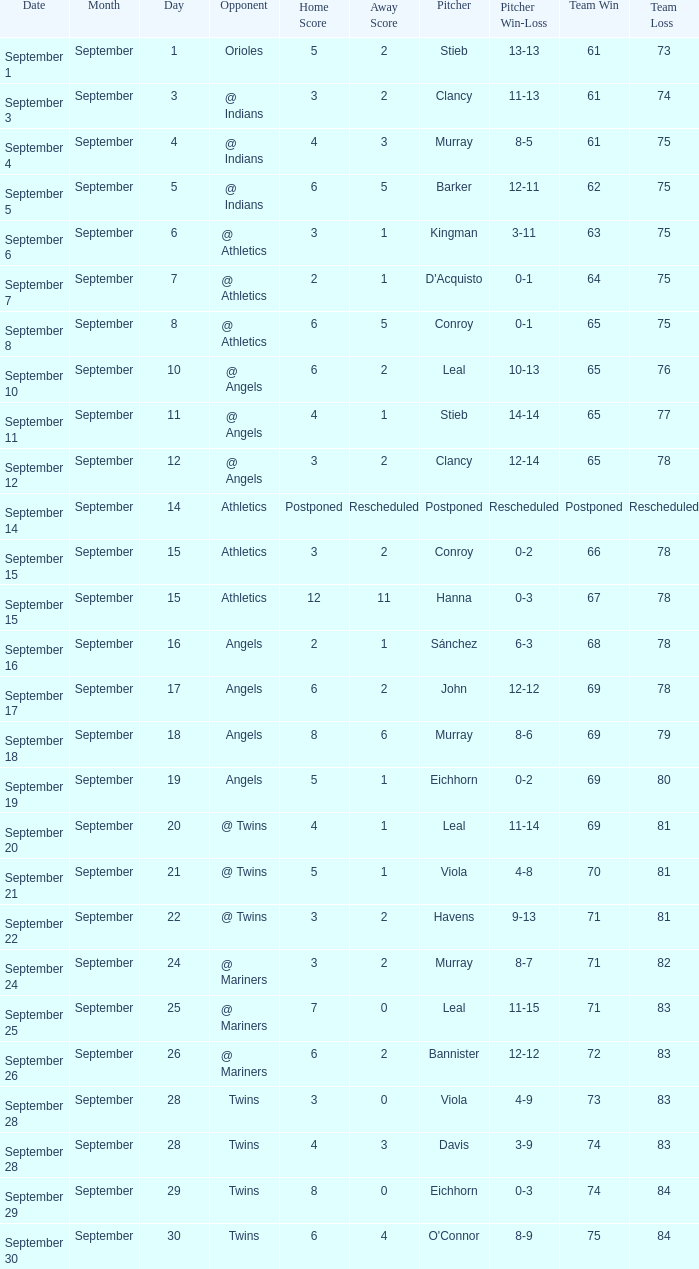Name the date for record of 74-84 September 29. 